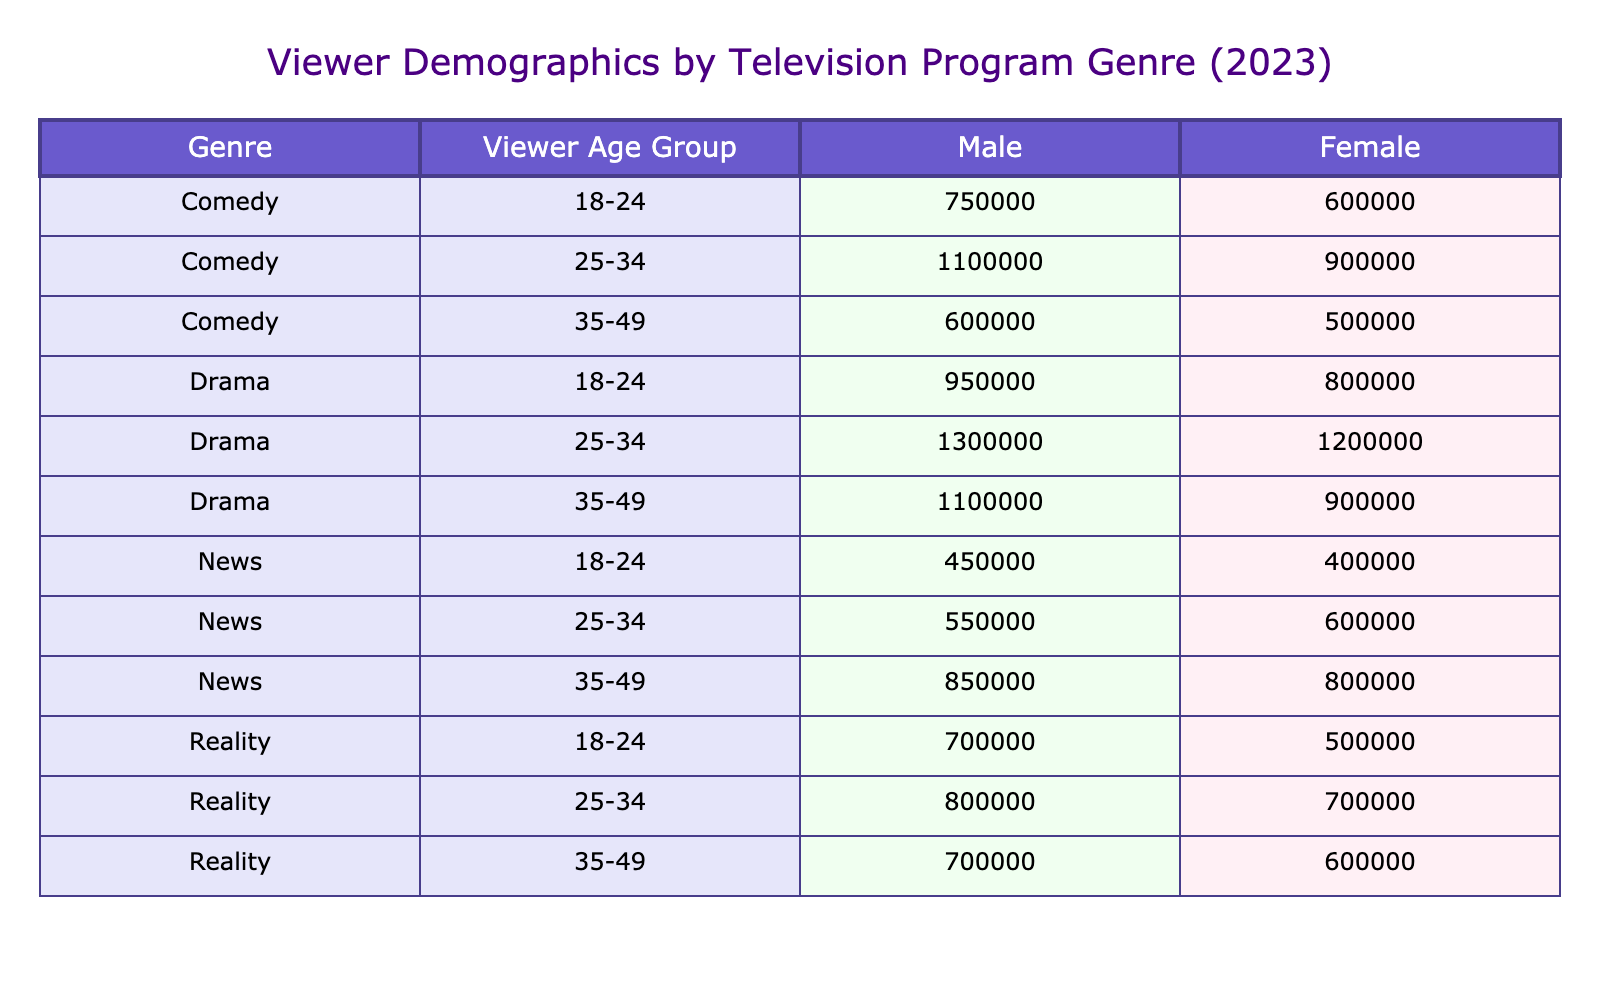What is the total number of male viewers for the Drama genre? The Drama genre has three age groups: 18-24, 25-34, and 35-49. The male viewer counts for these groups are 800,000 (18-24), 1,200,000 (25-34), and 900,000 (35-49). Adding these together: 800,000 + 1,200,000 + 900,000 = 2,900,000.
Answer: 2,900,000 Which age group has the highest number of female viewers in the Comedy genre? In the Comedy genre, the female viewer counts are: 750,000 for 18-24, 1,100,000 for 25-34, and 600,000 for 35-49. The highest count is in the 25-34 age group with 1,100,000 viewers.
Answer: 25-34 Is the total number of male viewers for Reality shows greater than the total for News shows? The total male viewers for Reality is 500,000 (18-24) + 700,000 (25-34) + 600,000 (35-49) = 1,800,000. For News, it’s 400,000 (18-24) + 600,000 (25-34) + 800,000 (35-49) = 1,800,000 as well. Since both totals are equal, the statement is false.
Answer: No What percentage of the total female viewers in the Drama genre is from the 35-49 age group? The female viewers for the Drama genre are as follows: 950,000 (18-24), 1,300,000 (25-34), and 1,100,000 (35-49). The total is 950,000 + 1,300,000 + 1,100,000 = 3,350,000. The count for the 35-49 age group is 1,100,000. The percentage is (1,100,000 / 3,350,000) * 100 = approximately 32.84%.
Answer: 32.84% Are there more viewers aged 18-24 for the Comedy genre compared to the Drama genre? For Comedy, the 18-24 age group has 750,000 viewers (600,000 male + 750,000 female), while for Drama, it has 1,750,000 viewers (800,000 male + 950,000 female). 1,750,000 (Drama) is greater than 1,350,000 (Comedy).
Answer: No What is the difference in the total viewer counts between the male and female viewers in the Reality genre? The male viewers in Reality are 500,000 (18-24) + 700,000 (25-34) + 600,000 (35-49) = 1,800,000. The female viewers are 700,000 (18-24) + 800,000 (25-34) + 700,000 (35-49) = 2,200,000. The difference is 2,200,000 - 1,800,000 = 400,000.
Answer: 400,000 Which genre has the highest total viewer count for the 25-34 age group among both genders? For the 25-34 age group: Drama has 1,200,000 (male) + 1,300,000 (female) = 2,500,000. Comedy has 900,000 (male) + 1,100,000 (female) = 2,000,000. Reality has 700,000 (male) + 800,000 (female) = 1,500,000. News has 600,000 (male) + 550,000 (female) = 1,150,000. The highest total viewer count is in the Drama genre with 2,500,000.
Answer: Drama 